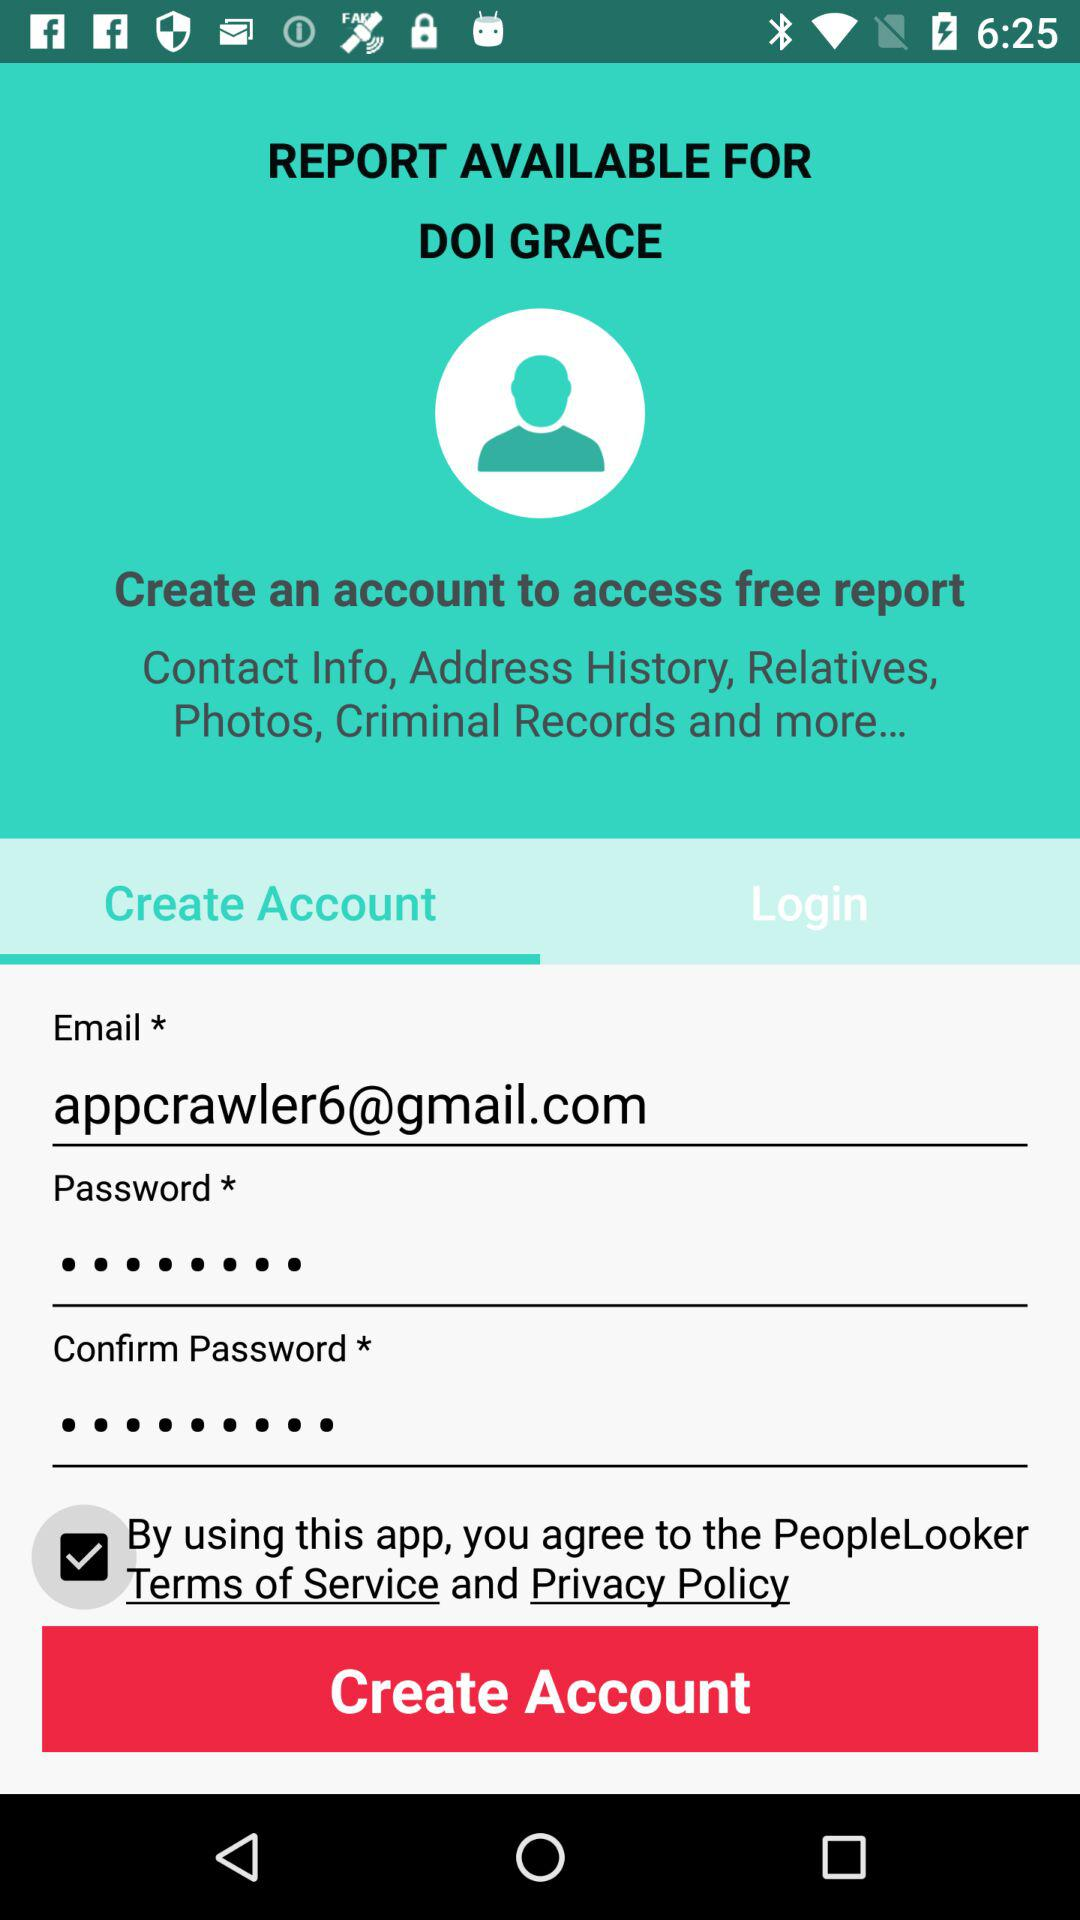What is the email address? The email address is appcrawler6@gmail.com. 